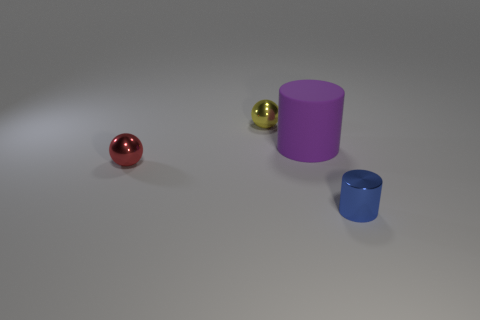The small metal thing that is to the right of the tiny yellow metallic sphere has what shape?
Make the answer very short. Cylinder. Do the tiny red thing and the purple object have the same shape?
Offer a terse response. No. Are there the same number of blue objects that are behind the red shiny thing and tiny cylinders?
Make the answer very short. No. The purple rubber object is what shape?
Your answer should be very brief. Cylinder. Is there any other thing that has the same color as the big rubber cylinder?
Make the answer very short. No. Does the cylinder that is left of the blue cylinder have the same size as the metal sphere that is on the right side of the red metal object?
Your answer should be compact. No. What shape is the shiny object that is to the right of the small sphere that is behind the large cylinder?
Your answer should be compact. Cylinder. Does the blue shiny cylinder have the same size as the metal ball that is right of the red thing?
Ensure brevity in your answer.  Yes. There is a cylinder in front of the sphere left of the thing behind the big thing; what size is it?
Keep it short and to the point. Small. What number of things are metallic spheres that are in front of the large purple rubber cylinder or tiny purple metal balls?
Provide a succinct answer. 1. 